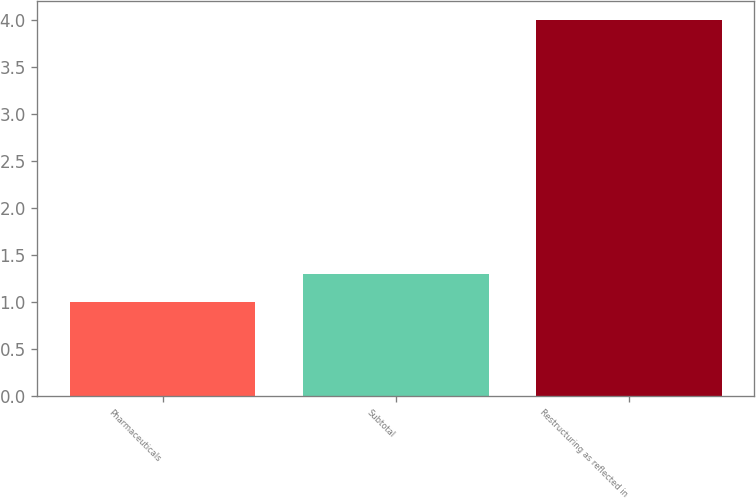Convert chart. <chart><loc_0><loc_0><loc_500><loc_500><bar_chart><fcel>Pharmaceuticals<fcel>Subtotal<fcel>Restructuring as reflected in<nl><fcel>1<fcel>1.3<fcel>4<nl></chart> 